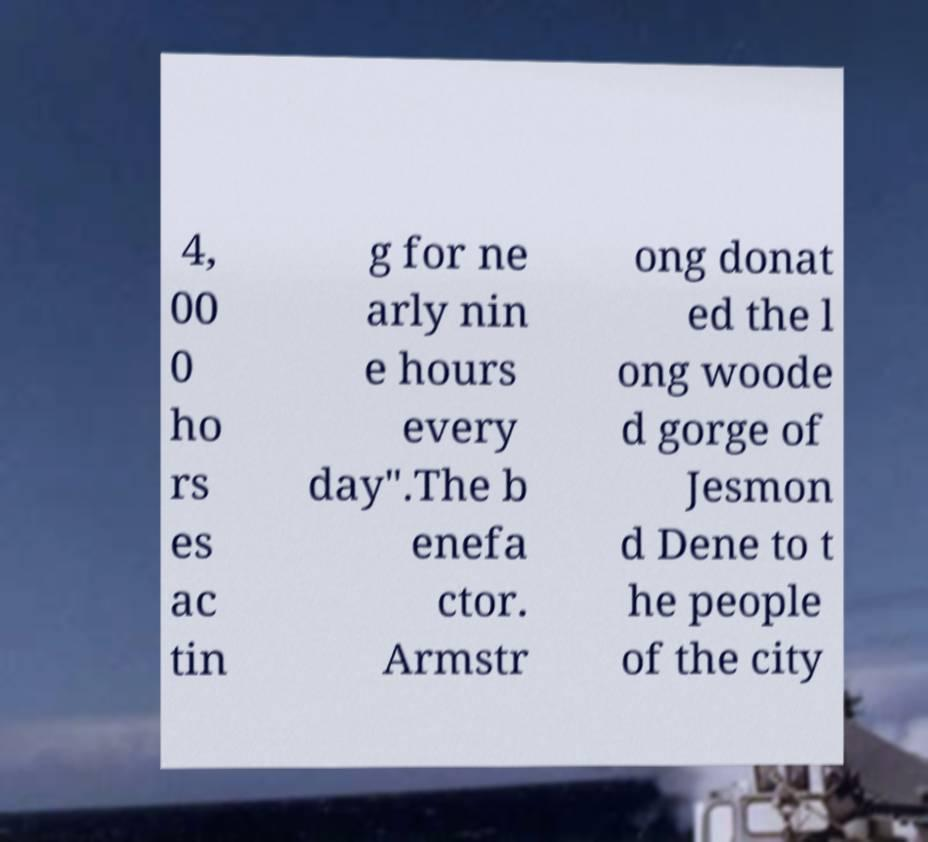Could you assist in decoding the text presented in this image and type it out clearly? 4, 00 0 ho rs es ac tin g for ne arly nin e hours every day".The b enefa ctor. Armstr ong donat ed the l ong woode d gorge of Jesmon d Dene to t he people of the city 